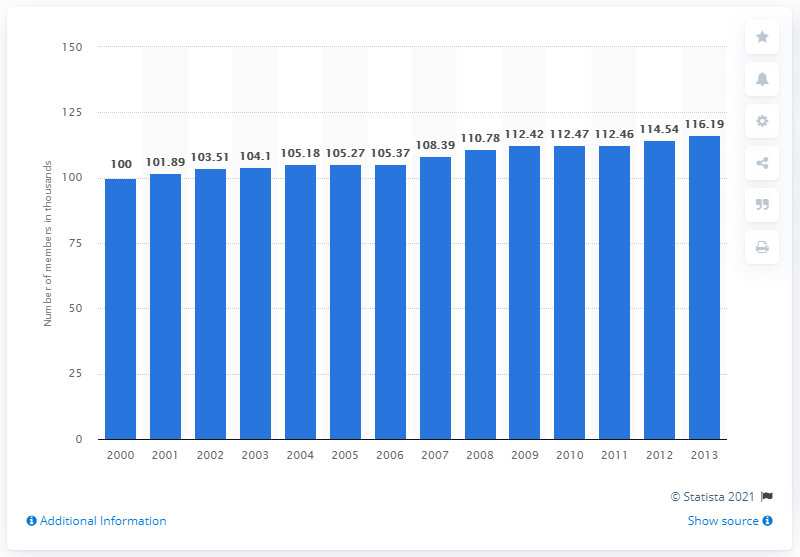Outline some significant characteristics in this image. In 2013, there were 116.19 members of the International Association of Theatrical Stage Employees. 